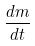<formula> <loc_0><loc_0><loc_500><loc_500>\frac { d m } { d t }</formula> 